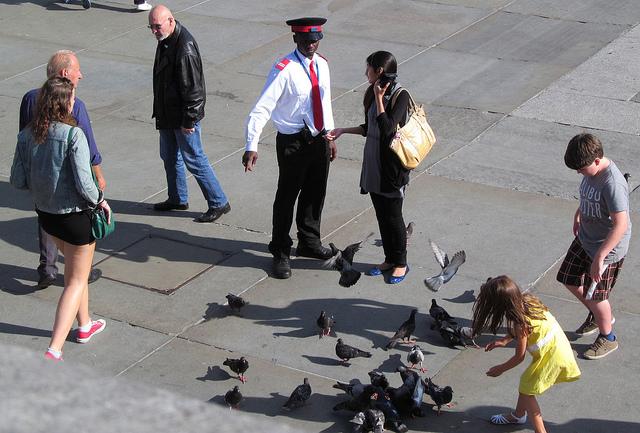Where is the green purse?
Give a very brief answer. Woman on left. What color dress is the little girl wearing?
Concise answer only. Yellow. What kind of birds are in this picture?
Write a very short answer. Pigeons. 